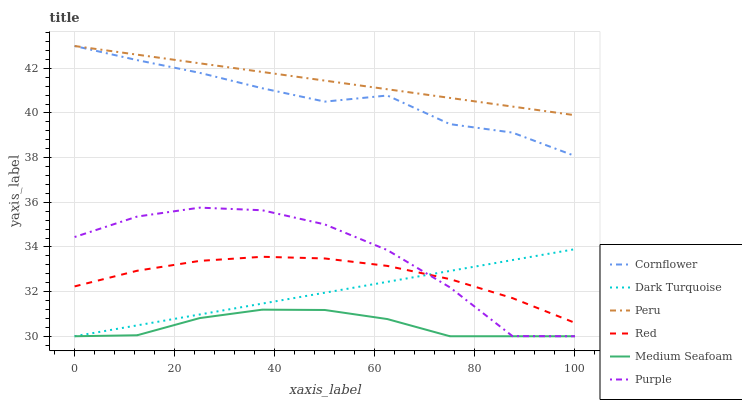Does Purple have the minimum area under the curve?
Answer yes or no. No. Does Purple have the maximum area under the curve?
Answer yes or no. No. Is Dark Turquoise the smoothest?
Answer yes or no. No. Is Dark Turquoise the roughest?
Answer yes or no. No. Does Peru have the lowest value?
Answer yes or no. No. Does Purple have the highest value?
Answer yes or no. No. Is Medium Seafoam less than Cornflower?
Answer yes or no. Yes. Is Peru greater than Red?
Answer yes or no. Yes. Does Medium Seafoam intersect Cornflower?
Answer yes or no. No. 